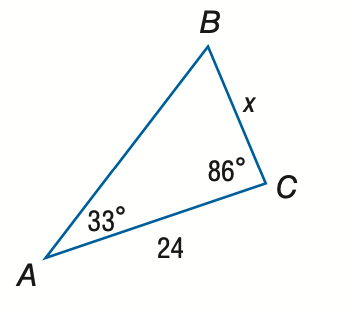Answer the mathemtical geometry problem and directly provide the correct option letter.
Question: Find x. Round the side measure to the nearest tenth.
Choices: A: 13.1 B: 14.9 C: 38.5 D: 44.0 B 